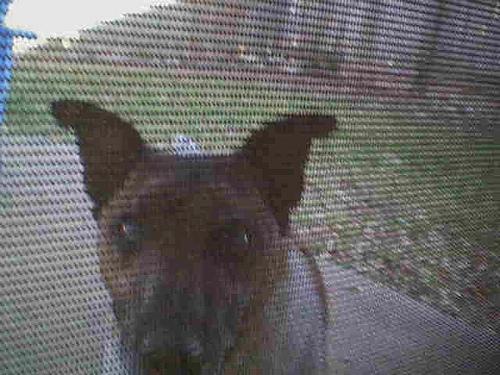Does this animal know the person who took the picture?
Keep it brief. Yes. What material is the fence made out of?
Quick response, please. Wood. What species of animal is in the scene?
Answer briefly. Dog. What color is the animals head?
Give a very brief answer. Brown. 